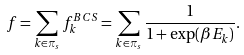<formula> <loc_0><loc_0><loc_500><loc_500>f = \sum _ { k \in \pi _ { s } } f ^ { B C S } _ { k } = \sum _ { k \in \pi _ { s } } \frac { 1 } { 1 + \exp ( \beta E _ { k } ) } .</formula> 